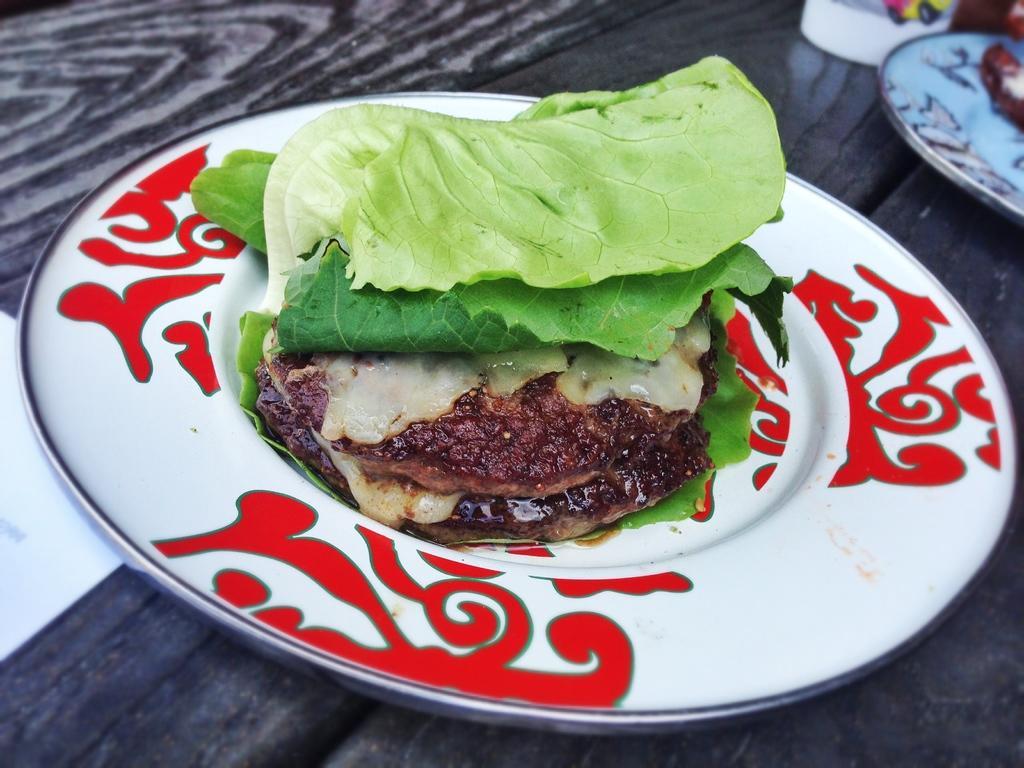Describe this image in one or two sentences. In this picture, we can see some food items kept on a plate on the table and we can see some objects on the table. 